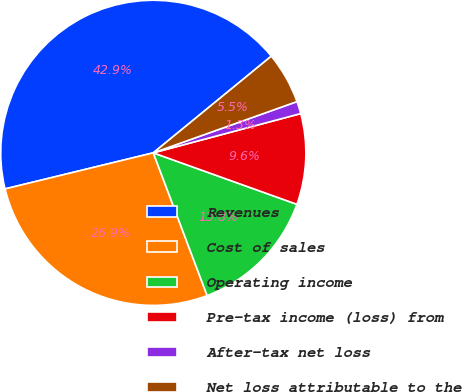<chart> <loc_0><loc_0><loc_500><loc_500><pie_chart><fcel>Revenues<fcel>Cost of sales<fcel>Operating income<fcel>Pre-tax income (loss) from<fcel>After-tax net loss<fcel>Net loss attributable to the<nl><fcel>42.88%<fcel>26.94%<fcel>13.78%<fcel>9.62%<fcel>1.31%<fcel>5.47%<nl></chart> 